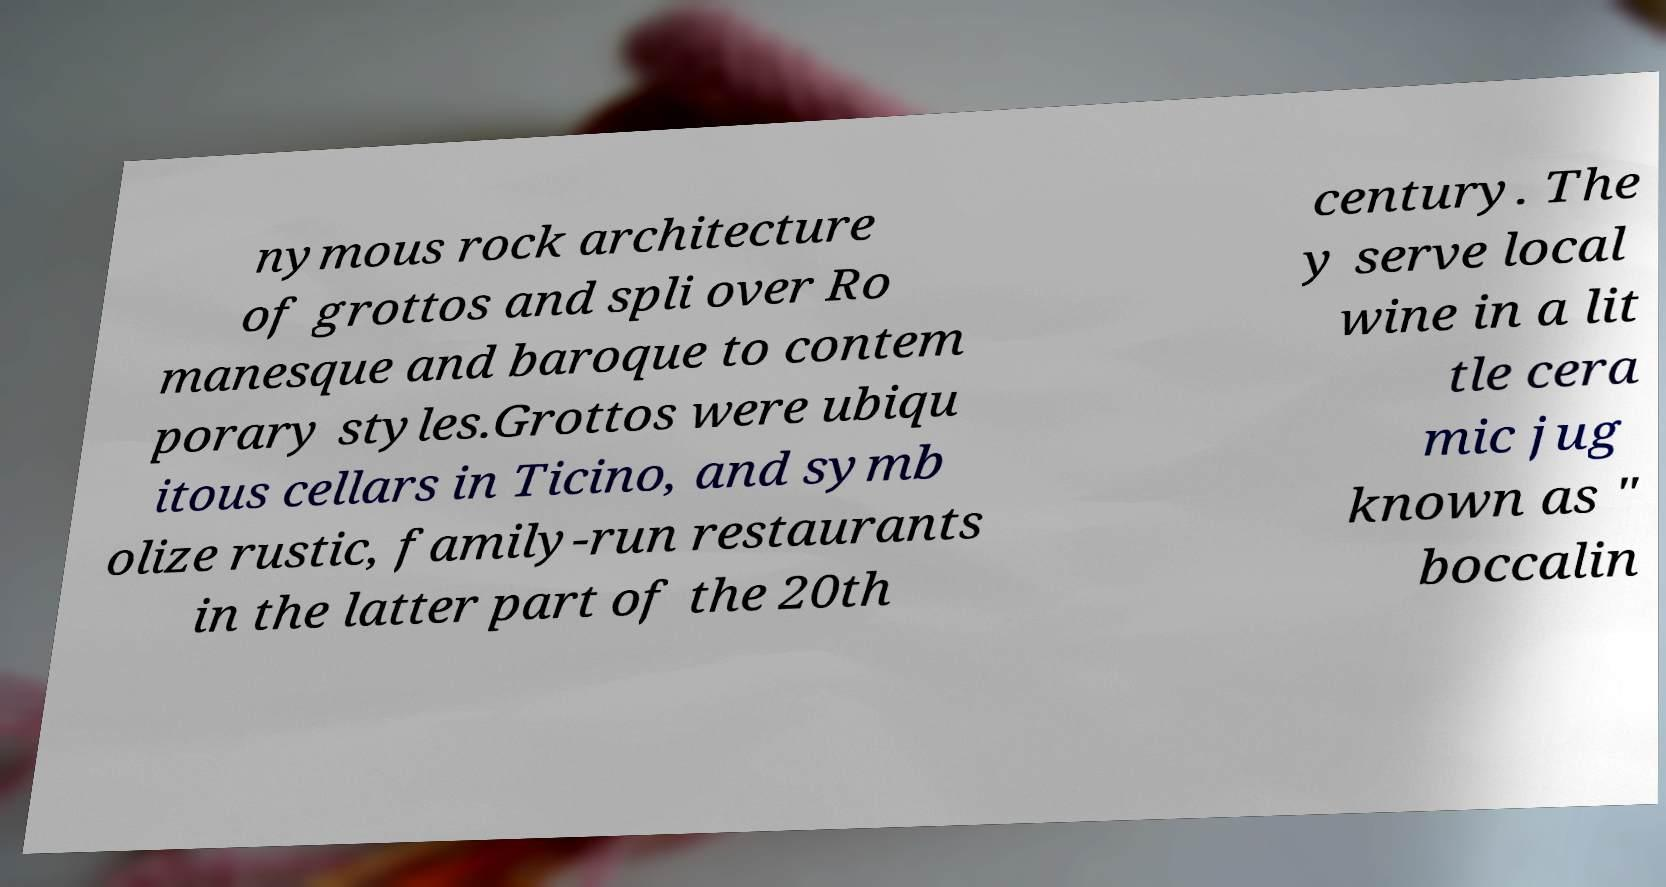There's text embedded in this image that I need extracted. Can you transcribe it verbatim? nymous rock architecture of grottos and spli over Ro manesque and baroque to contem porary styles.Grottos were ubiqu itous cellars in Ticino, and symb olize rustic, family-run restaurants in the latter part of the 20th century. The y serve local wine in a lit tle cera mic jug known as " boccalin 